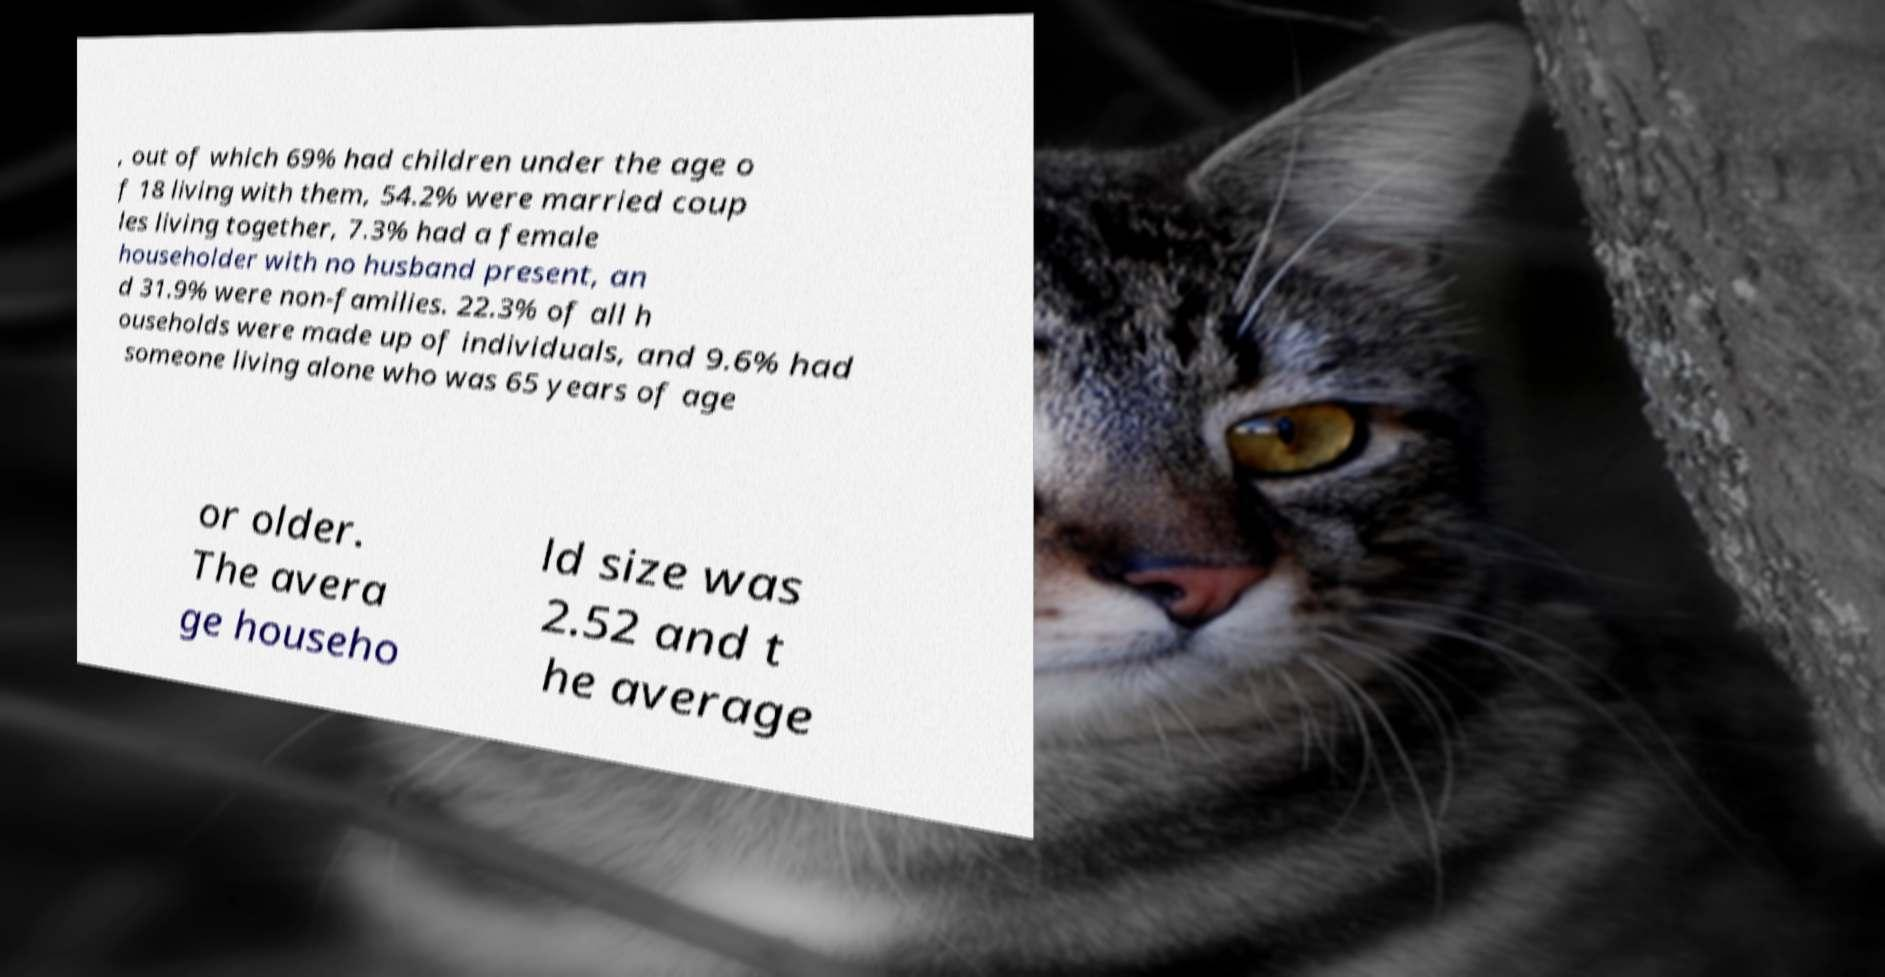Please read and relay the text visible in this image. What does it say? , out of which 69% had children under the age o f 18 living with them, 54.2% were married coup les living together, 7.3% had a female householder with no husband present, an d 31.9% were non-families. 22.3% of all h ouseholds were made up of individuals, and 9.6% had someone living alone who was 65 years of age or older. The avera ge househo ld size was 2.52 and t he average 